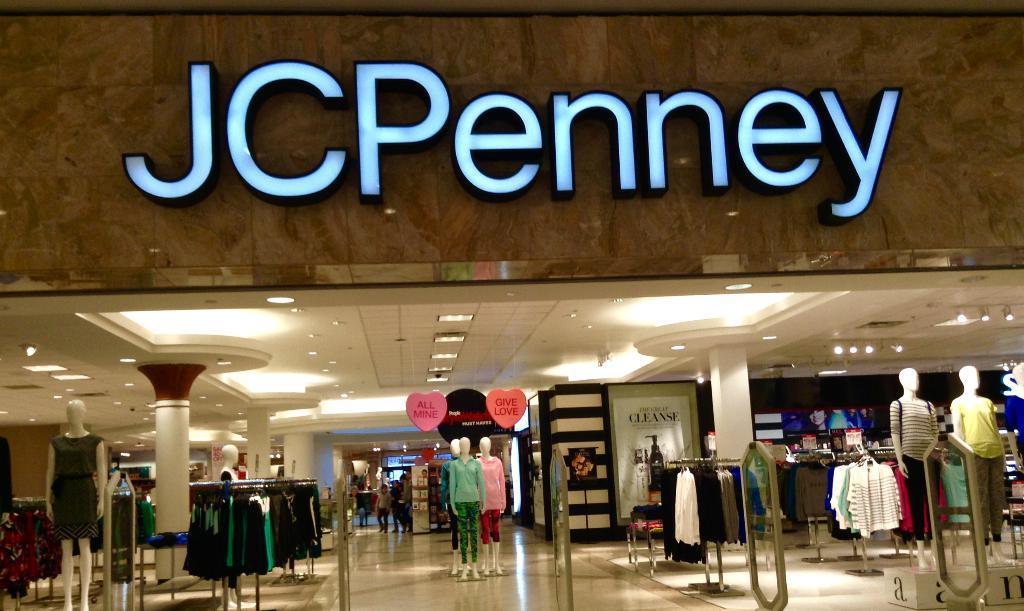Please provide a concise description of this image. This image looks like a shopping mall, there are some mannequins, pillars, clothes hanged to the stands, also we can see some boards with text on it, at the top we can see some lights and on the shop we can see some text. 